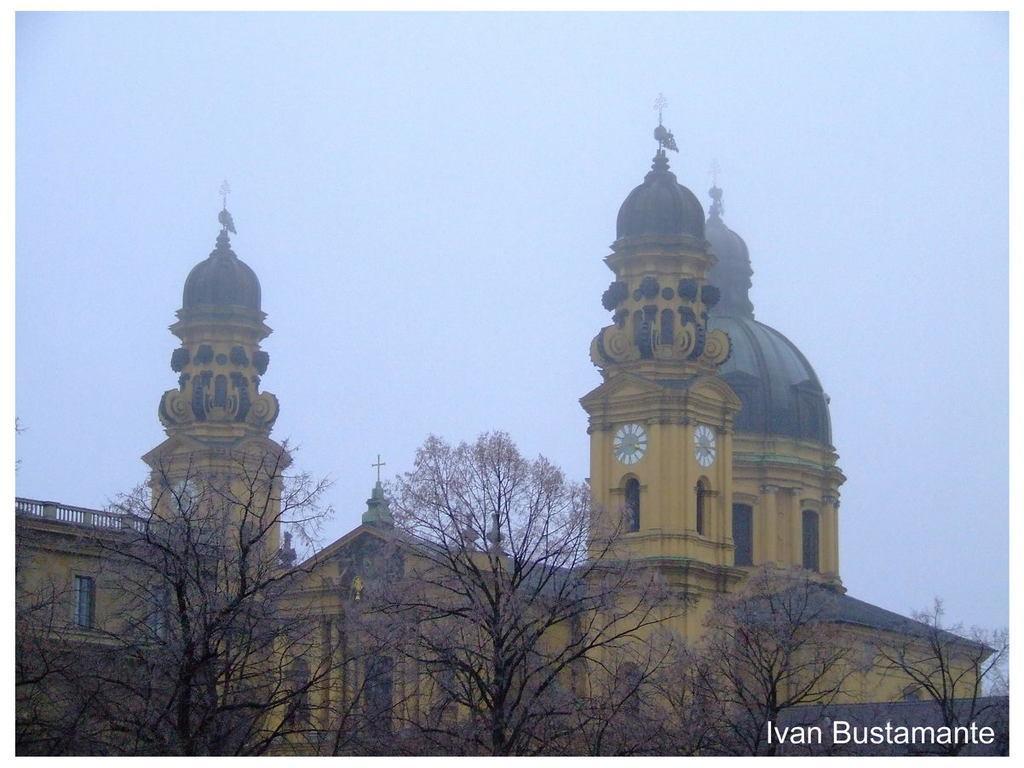Describe this image in one or two sentences. In the center of the image there is a building. At the bottom we can see trees. In the background there is sky. 